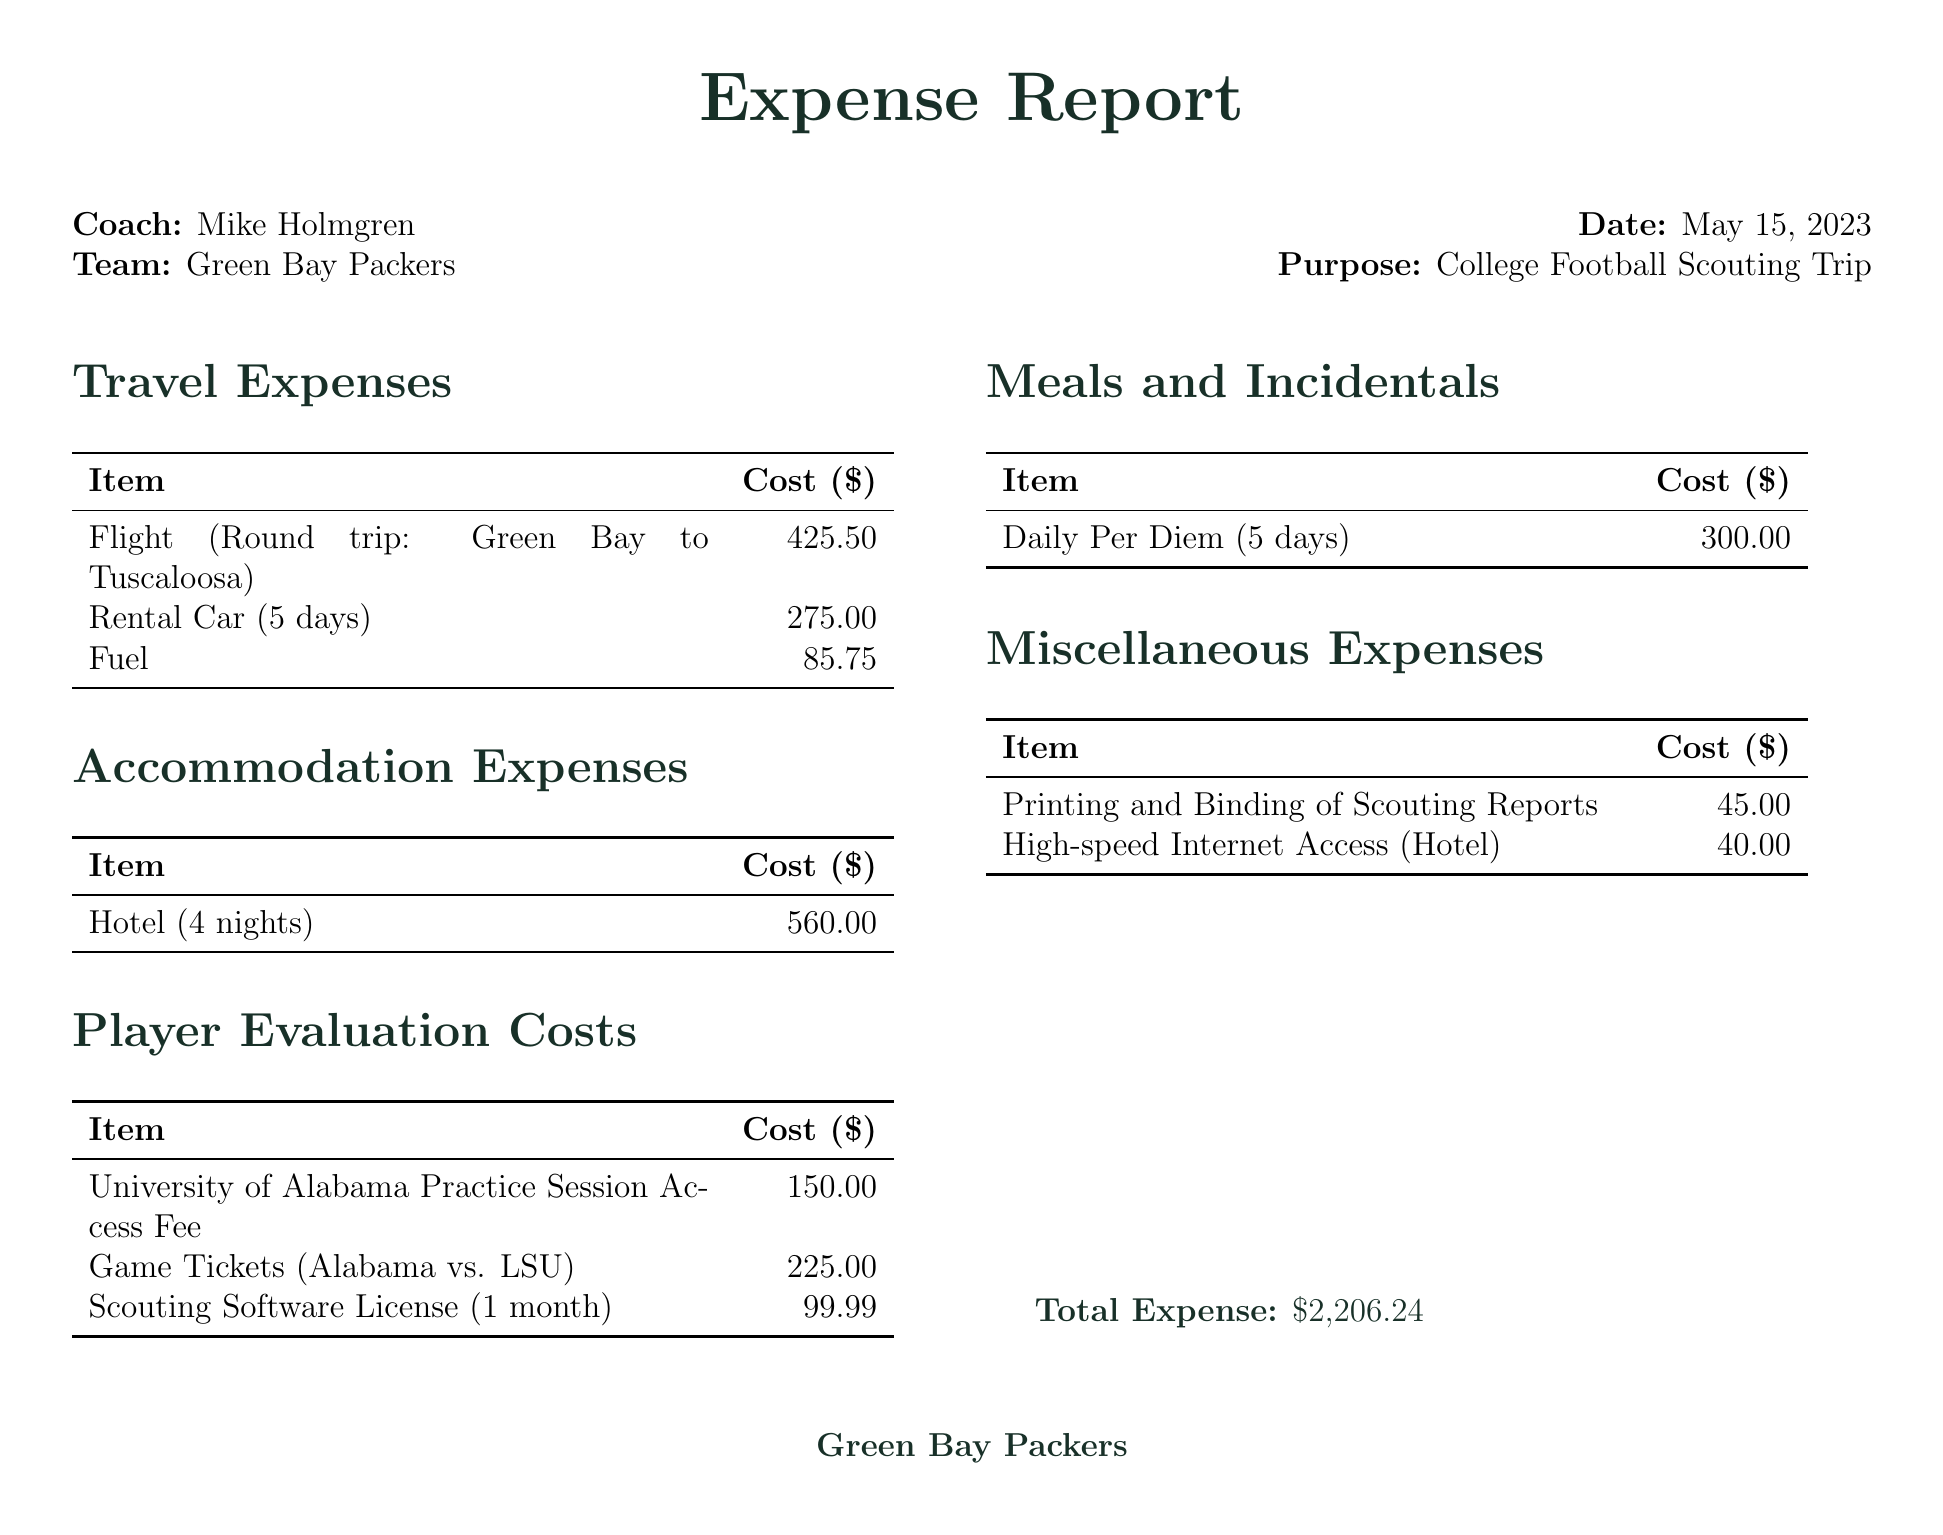What is the date of the scouting trip? The date is directly mentioned in the document as May 15, 2023.
Answer: May 15, 2023 Who is the coach associated with this invoice? The coach's name is prominently listed in the document.
Answer: Mike Holmgren What hotel was used for accommodation? The document specifies the hotel name under accommodation expenses.
Answer: Hilton Garden Inn Tuscaloosa What is the total expense reported? The total expense is clearly stated at the end of the expenses section.
Answer: $2,206.24 How many nights was the hotel booked for? The nights are detailed in the accommodation expenses section of the document.
Answer: 4 nights What was the cost of the flight? The cost of the flight is provided as part of the travel expenses.
Answer: $425.50 What type of player was primarily evaluated? The document specifically mentions the focus of player evaluations in the notes section.
Answer: Offensive linemen and defensive backs What was the cost for daily per diem? The daily per diem amount is listed in the meals and incidentals section.
Answer: $300.00 What software license is mentioned in the player evaluation costs? The software used is specified in the player evaluation costs section of the document.
Answer: Hudl 